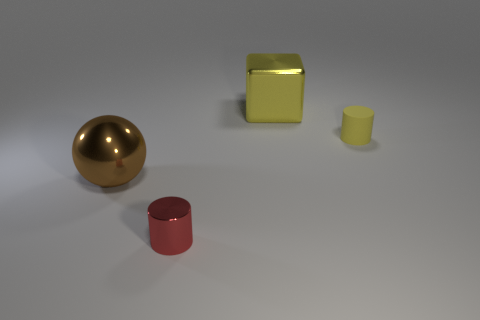Add 2 large blocks. How many objects exist? 6 Subtract all balls. How many objects are left? 3 Subtract 0 purple blocks. How many objects are left? 4 Subtract all big brown metallic objects. Subtract all tiny red cylinders. How many objects are left? 2 Add 1 small yellow rubber objects. How many small yellow rubber objects are left? 2 Add 2 green metallic things. How many green metallic things exist? 2 